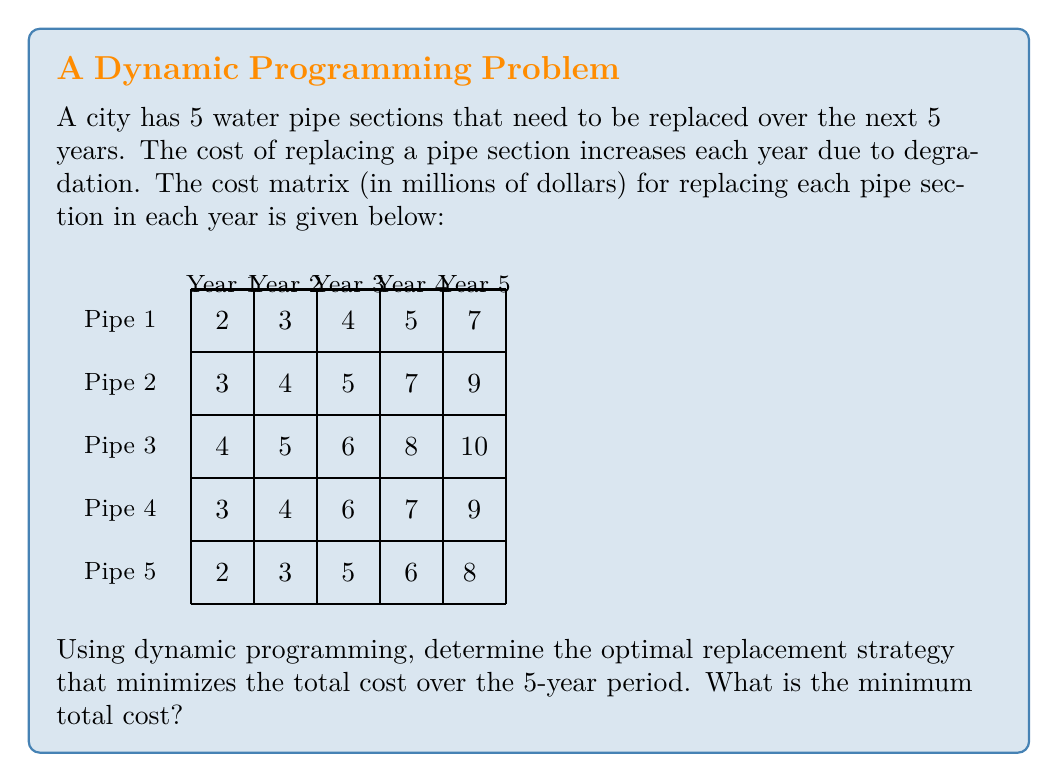Solve this math problem. To solve this problem using dynamic programming, we'll work backwards from the last year to the first year. Let $f(i,j)$ be the minimum cost to replace the remaining pipes from year $i$ to year 5, given that $j$ pipes have already been replaced.

Step 1: Initialize the base case for year 5.
$f(5,4) = \min(\text{costs in year 5}) = 7$

Step 2: Work backwards from year 4 to year 1.
For each year $i$ and number of pipes already replaced $j$, we calculate:

$$f(i,j) = \min_{k=1}^{5-j} (\text{cost}[5-k][i-1] + f(i+1,j+1))$$

Where $k$ is the pipe section we choose to replace in the current year.

Year 4:
$f(4,3) = \min(5+7, 7+7, 6+7, 7+7, 8+7) = 12$

Year 3:
$f(3,2) = \min(4+12, 5+12, 6+12, 7+12, 10+12) = 16$

Year 2:
$f(2,1) = \min(3+16, 4+16, 5+16, 7+16, 9+16) = 19$

Year 1:
$f(1,0) = \min(2+19, 3+19, 4+19, 3+19, 2+19) = 21$

Step 3: The minimum total cost is $f(1,0) = 21$ million dollars.

To find the optimal strategy, we trace back the decisions:
Year 1: Replace pipe section 1 or 5 (cost: 2)
Year 2: Replace pipe section 1 (cost: 3)
Year 3: Replace pipe section 1 (cost: 4)
Year 4: Replace pipe section 1 or 4 (cost: 5)
Year 5: Replace the last remaining pipe section (cost: 7)
Answer: $21 million 